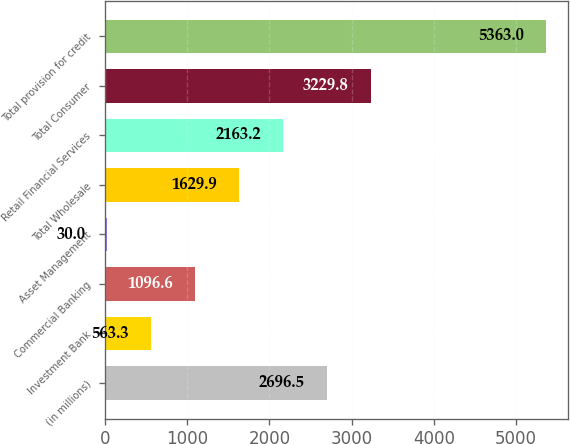Convert chart. <chart><loc_0><loc_0><loc_500><loc_500><bar_chart><fcel>(in millions)<fcel>Investment Bank<fcel>Commercial Banking<fcel>Asset Management<fcel>Total Wholesale<fcel>Retail Financial Services<fcel>Total Consumer<fcel>Total provision for credit<nl><fcel>2696.5<fcel>563.3<fcel>1096.6<fcel>30<fcel>1629.9<fcel>2163.2<fcel>3229.8<fcel>5363<nl></chart> 